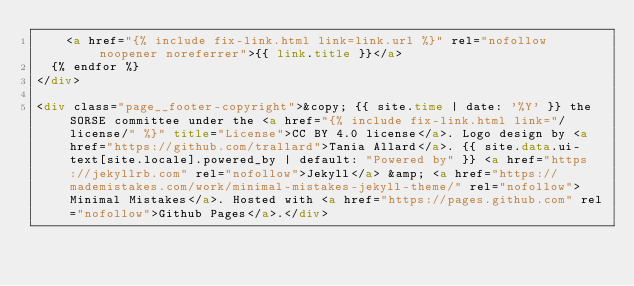Convert code to text. <code><loc_0><loc_0><loc_500><loc_500><_HTML_>    <a href="{% include fix-link.html link=link.url %}" rel="nofollow noopener noreferrer">{{ link.title }}</a>
  {% endfor %}
</div>

<div class="page__footer-copyright">&copy; {{ site.time | date: '%Y' }} the SORSE committee under the <a href="{% include fix-link.html link="/license/" %}" title="License">CC BY 4.0 license</a>. Logo design by <a href="https://github.com/trallard">Tania Allard</a>. {{ site.data.ui-text[site.locale].powered_by | default: "Powered by" }} <a href="https://jekyllrb.com" rel="nofollow">Jekyll</a> &amp; <a href="https://mademistakes.com/work/minimal-mistakes-jekyll-theme/" rel="nofollow">Minimal Mistakes</a>. Hosted with <a href="https://pages.github.com" rel="nofollow">Github Pages</a>.</div>
</code> 